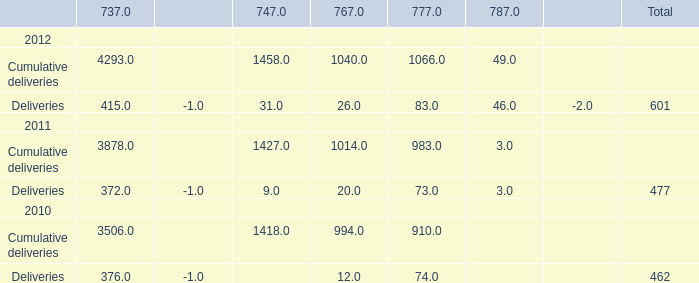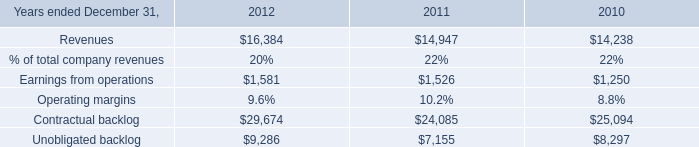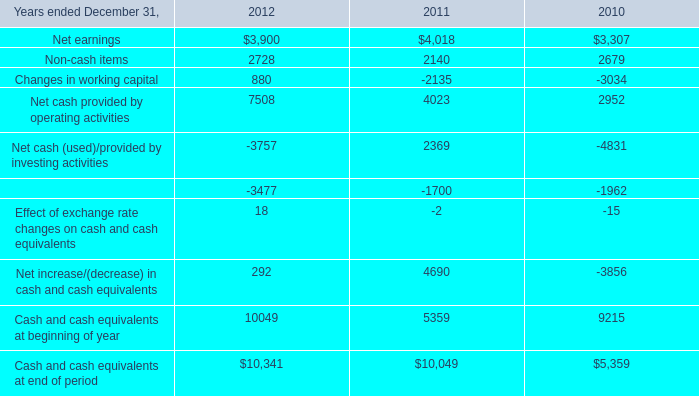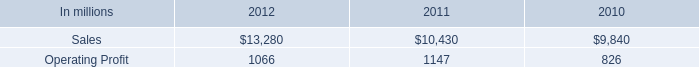What's the average of Unobligated backlog of 2011, and Cash and cash equivalents at beginning of year of 2011 ? 
Computations: ((7155.0 + 5359.0) / 2)
Answer: 6257.0. 